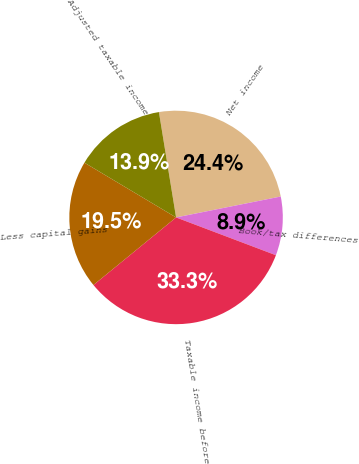Convert chart. <chart><loc_0><loc_0><loc_500><loc_500><pie_chart><fcel>Net income<fcel>Book/tax differences<fcel>Taxable income before<fcel>Less capital gains<fcel>Adjusted taxable income<nl><fcel>24.43%<fcel>8.9%<fcel>33.33%<fcel>19.48%<fcel>13.86%<nl></chart> 